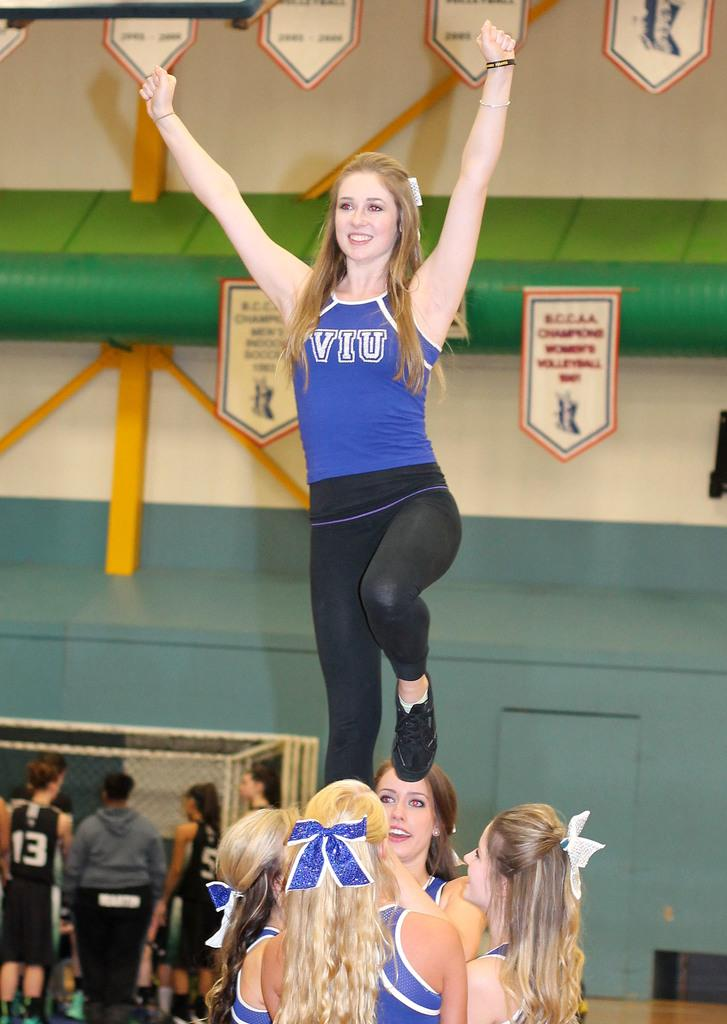<image>
Create a compact narrative representing the image presented. Cheerleaders wearing VIU uniforms do a routine in a gym. 